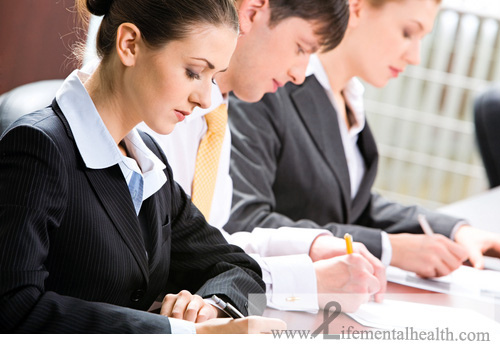Read all the text in this image. WWW.Lifementalhealth 